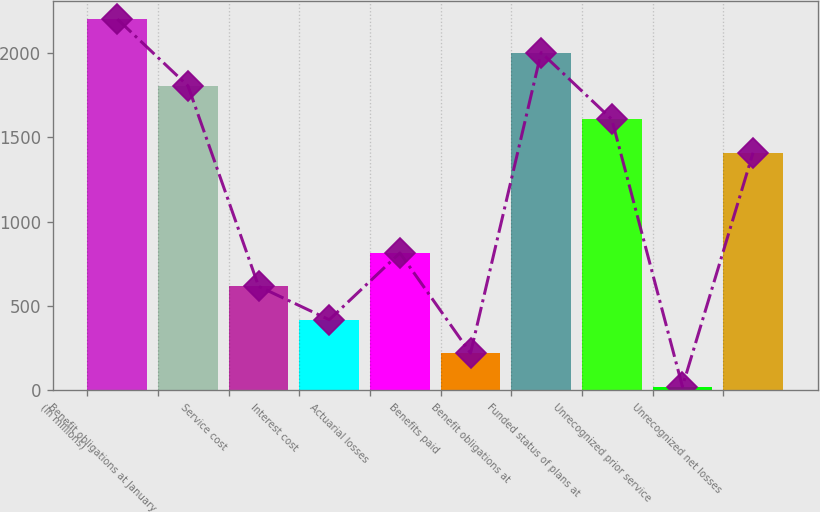<chart> <loc_0><loc_0><loc_500><loc_500><bar_chart><fcel>(In millions)<fcel>Benefit obligations at January<fcel>Service cost<fcel>Interest cost<fcel>Actuarial losses<fcel>Benefits paid<fcel>Benefit obligations at<fcel>Funded status of plans at<fcel>Unrecognized prior service<fcel>Unrecognized net losses<nl><fcel>2200<fcel>1804<fcel>616<fcel>418<fcel>814<fcel>220<fcel>2002<fcel>1606<fcel>22<fcel>1408<nl></chart> 